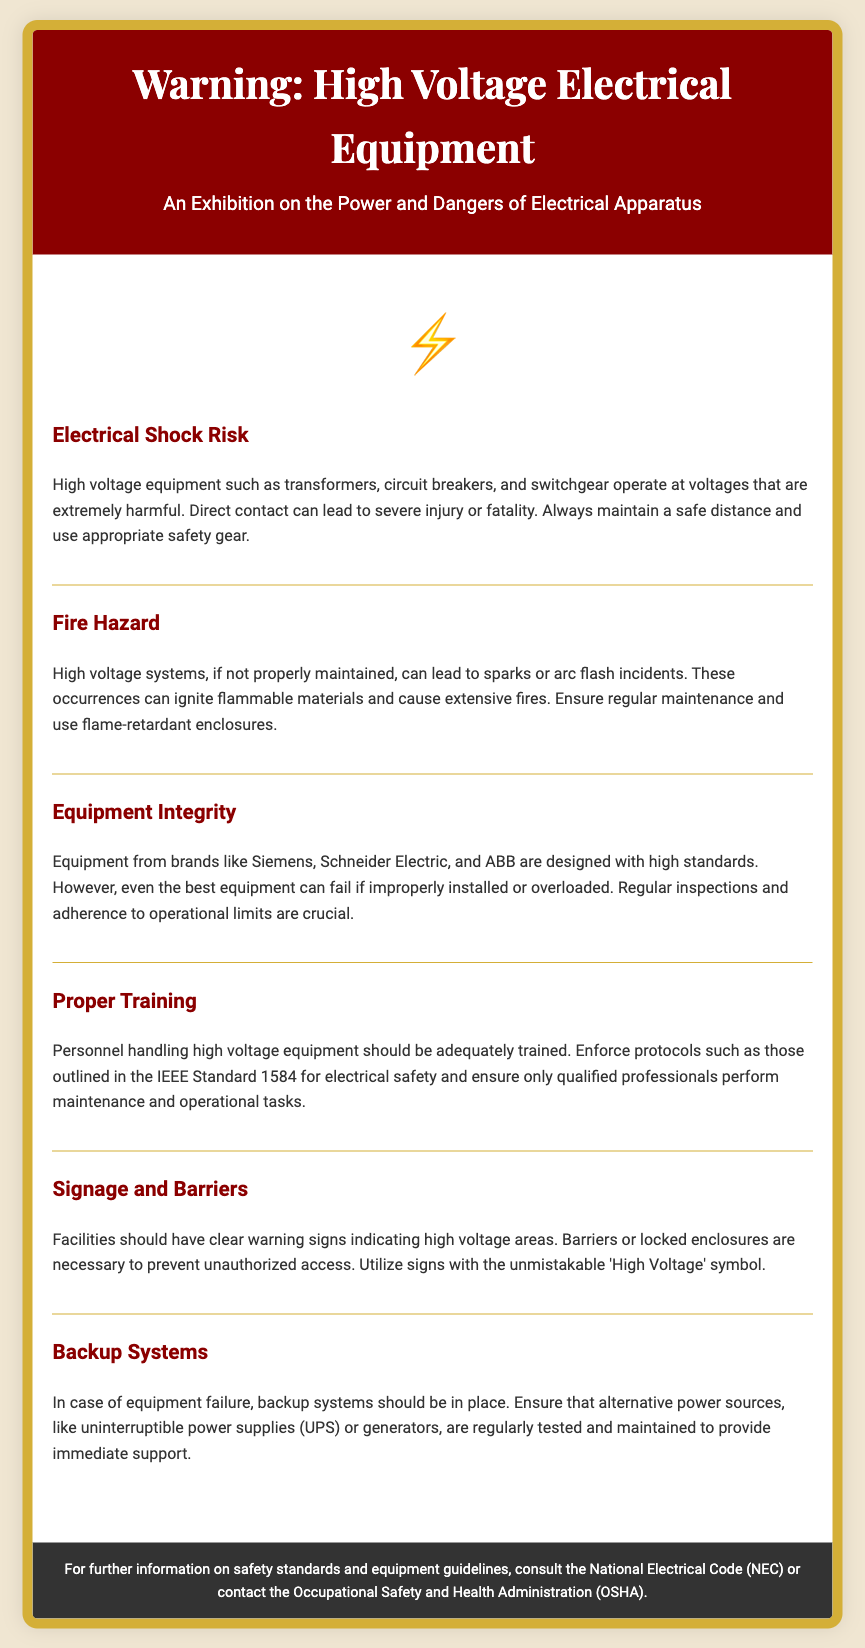What is the title of the exhibition? The title is prominently displayed at the top of the document.
Answer: Warning: High Voltage Electrical Equipment What symbol is used to indicate danger? The document features a warning symbol for high voltage.
Answer: ⚡ Which standard is mentioned for electrical safety? The IEEE standard is referenced in the section about proper training.
Answer: IEEE Standard 1584 What type of hazard can high voltage systems lead to if not maintained? The document highlights the dangers associated with improper maintenance of high voltage systems.
Answer: Fire Hazard What equipment brands are mentioned in the document? The section on equipment integrity specifically names three brands.
Answer: Siemens, Schneider Electric, ABB What is recommended for personnel handling high voltage equipment? The section on proper training emphasizes the importance of training.
Answer: Adequately trained What safety measure is suggested for unauthorized access prevention? The section on signage and barriers discusses measures to restrict access.
Answer: Barriers or locked enclosures What is necessary to provide immediate support during equipment failure? The section on backup systems discusses provisions in case of failure.
Answer: Backup systems How frequently should equipment be inspected? The document suggests regular inspections for maintaining equipment.
Answer: Regularly 